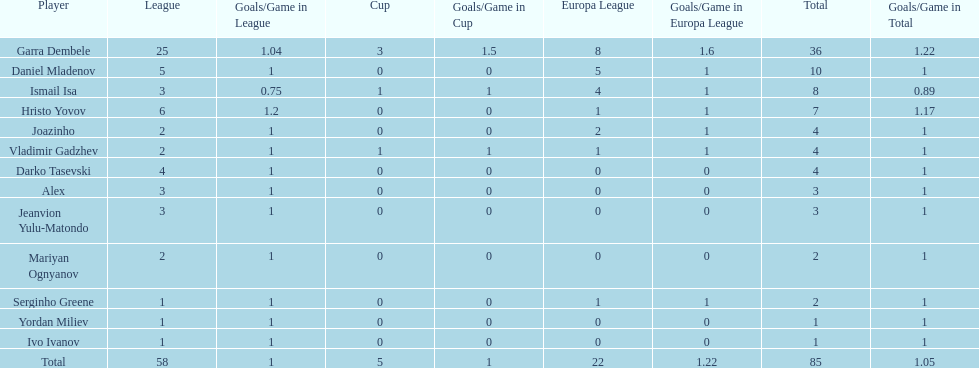How many goals did ismail isa score this season? 8. 